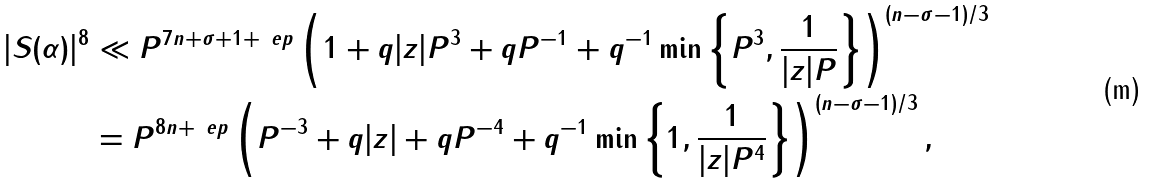Convert formula to latex. <formula><loc_0><loc_0><loc_500><loc_500>| S ( \alpha ) | ^ { 8 } & \ll P ^ { 7 n + \sigma + 1 + \ e p } \left ( 1 + q | z | P ^ { 3 } + q P ^ { - 1 } + q ^ { - 1 } \min \left \{ P ^ { 3 } , \frac { 1 } { | z | P } \right \} \right ) ^ { ( n - \sigma - 1 ) / 3 } \\ & = P ^ { 8 n + \ e p } \left ( P ^ { - 3 } + q | z | + q P ^ { - 4 } + q ^ { - 1 } \min \left \{ 1 , \frac { 1 } { | z | P ^ { 4 } } \right \} \right ) ^ { ( n - \sigma - 1 ) / 3 } ,</formula> 